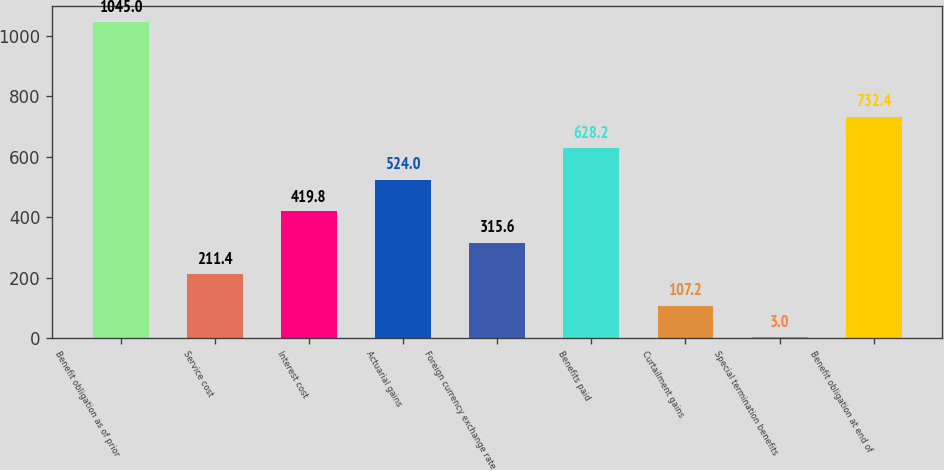<chart> <loc_0><loc_0><loc_500><loc_500><bar_chart><fcel>Benefit obligation as of prior<fcel>Service cost<fcel>Interest cost<fcel>Actuarial gains<fcel>Foreign currency exchange rate<fcel>Benefits paid<fcel>Curtailment gains<fcel>Special termination benefits<fcel>Benefit obligation at end of<nl><fcel>1045<fcel>211.4<fcel>419.8<fcel>524<fcel>315.6<fcel>628.2<fcel>107.2<fcel>3<fcel>732.4<nl></chart> 